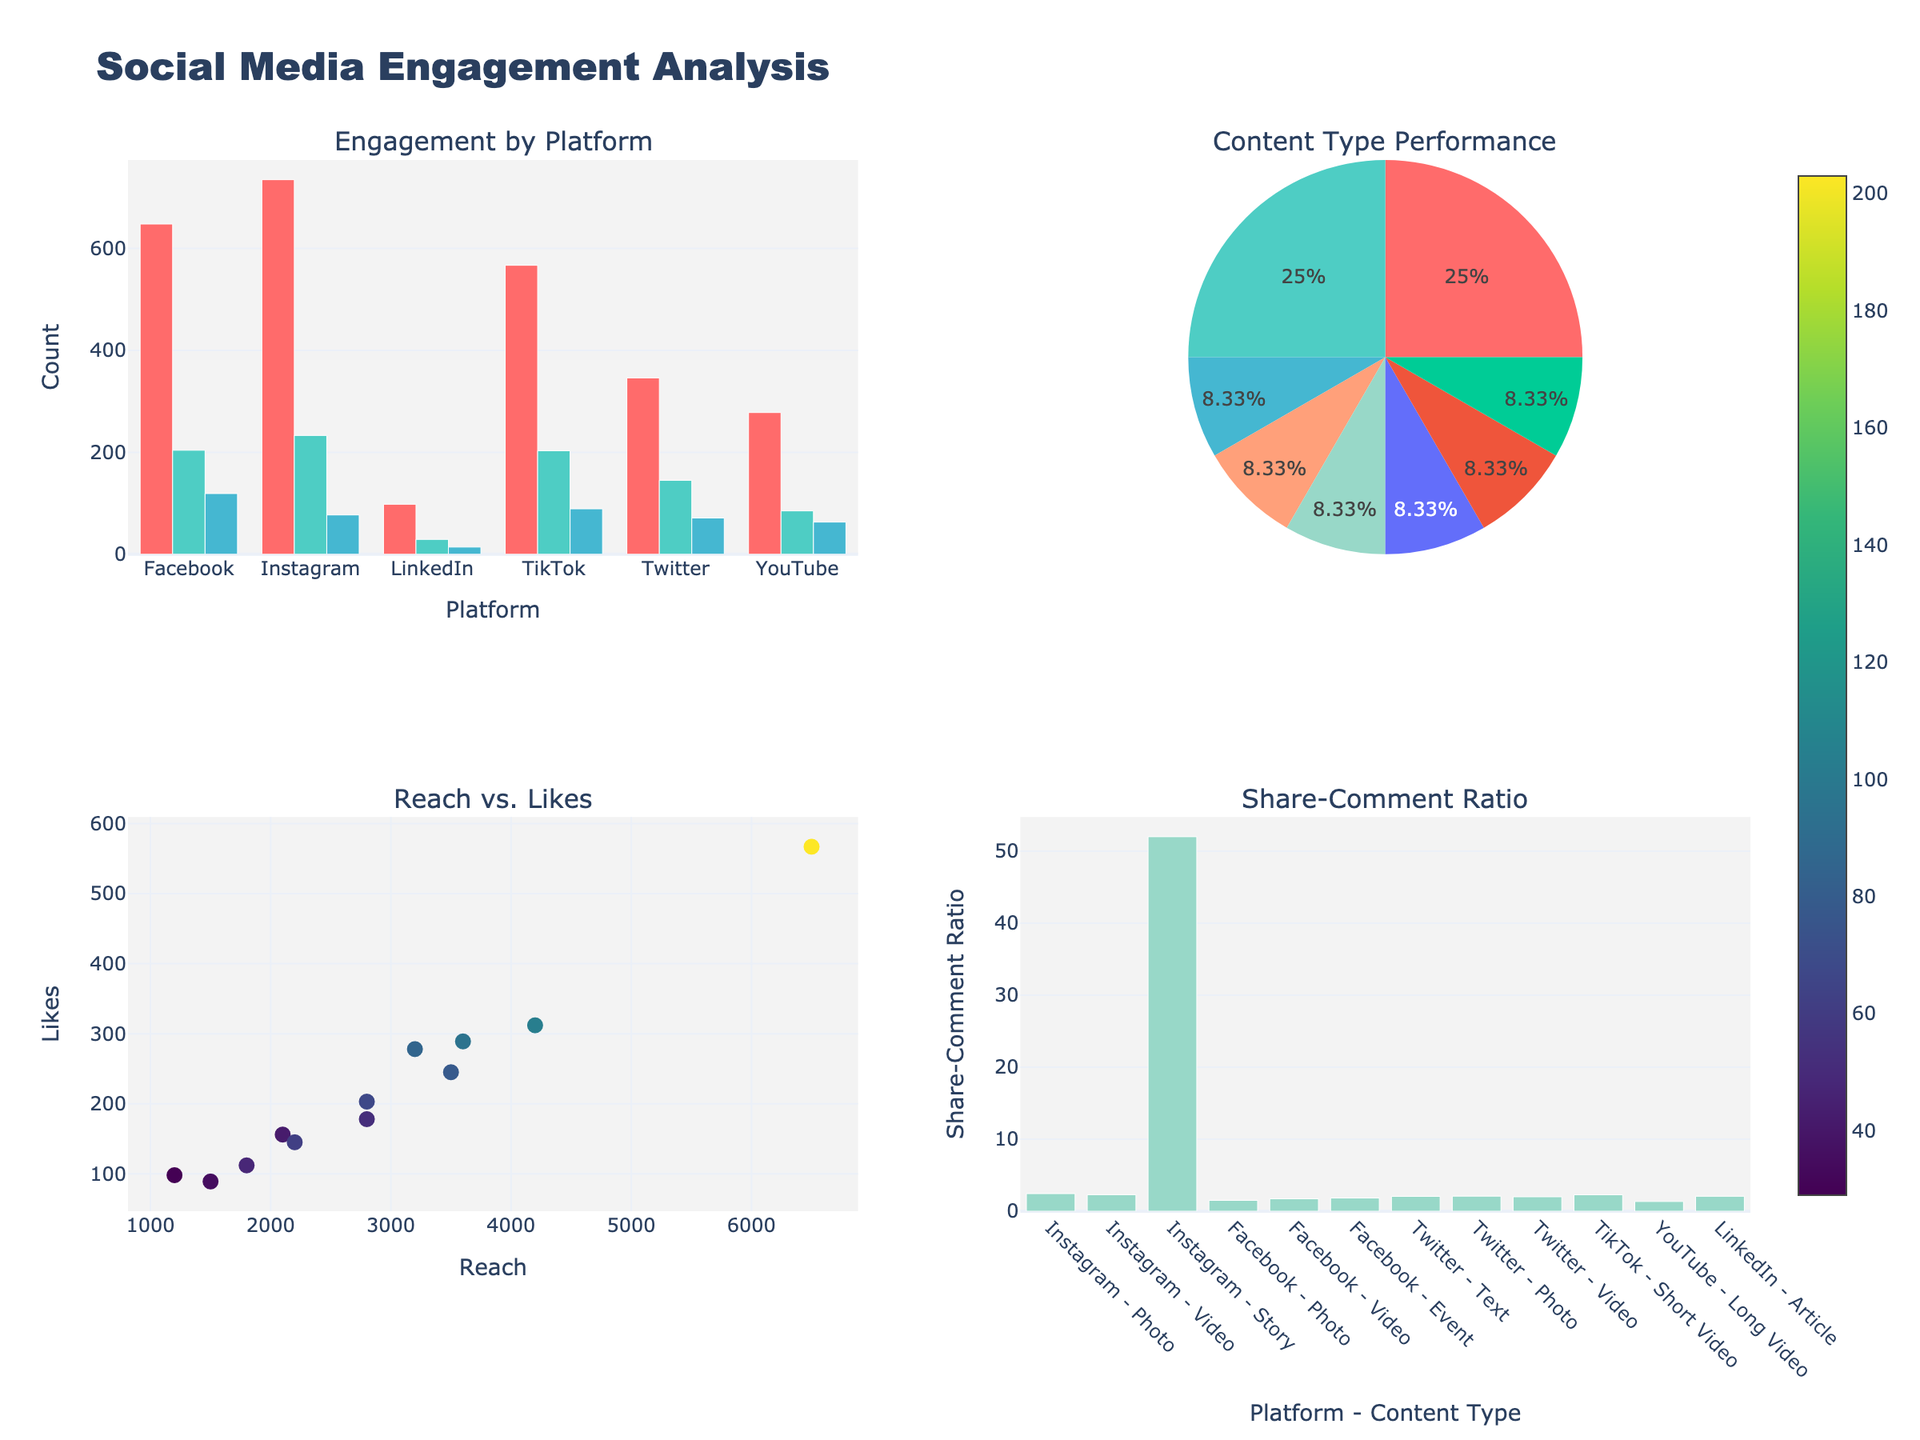What's the overall title of the figure? The overall title can be found at the top center part of the figure, which provides a summary of the entire set of plots.
Answer: Social Media Engagement Analysis Which platform has the highest total number of comments? From the bar chart in the first subplot (Engagement by Platform), we observe that Instagram has the highest bar for comments.
Answer: Instagram What content type has the largest share in the pie chart? In the pie chart located in the second subplot (Content Type Performance), the largest segment corresponds to 'Video'.
Answer: Video How many content types are shown in the pie chart? By counting the segments in the pie chart in the second subplot, we identify the total number of unique content types.
Answer: 6 Which platform-content type combination has the highest share-comment ratio? From the bar chart in the fourth subplot (Share-Comment Ratio), look for the bar with the highest value. This corresponds to TikTok with 'Short Video'.
Answer: TikTok - Short Video Compare the number of likes for Instagram videos versus Facebook events. Which one is higher? In the first subplot (Engagement by Platform), compare the height of the bars for likes between 'Instagram Video' and 'Facebook Event'. Instagram Video has 312 likes, while Facebook Event has 289 likes.
Answer: Instagram Video What is the Reach value that corresponds to 200 likes in the scatter plot? Locate a point on the third subplot (Reach vs. Likes) around the x-axis of 200 likes and check the corresponding y-value on the Reach axis.
Answer: Approximately 2800 What is the Share-Comment ratio for articles on LinkedIn? The fourth subplot (Share-Comment Ratio) shows the ratio for 'LinkedIn - Article'. Find the bar corresponding to it and read its height value.
Answer: 2.07 (Approximately 29/14) What platform has the widest range of Likes in the scatter plot? In the third subplot (Reach vs. Likes), observe the spread of points. Instagram shows the widest range with points from 178 to 312 likes.
Answer: Instagram How many platforms have more than 200 shares? Refer to the first subplot (Engagement by Platform), count the platforms where the bar for shares exceeds 200. Only TikTok meets this condition.
Answer: 1 